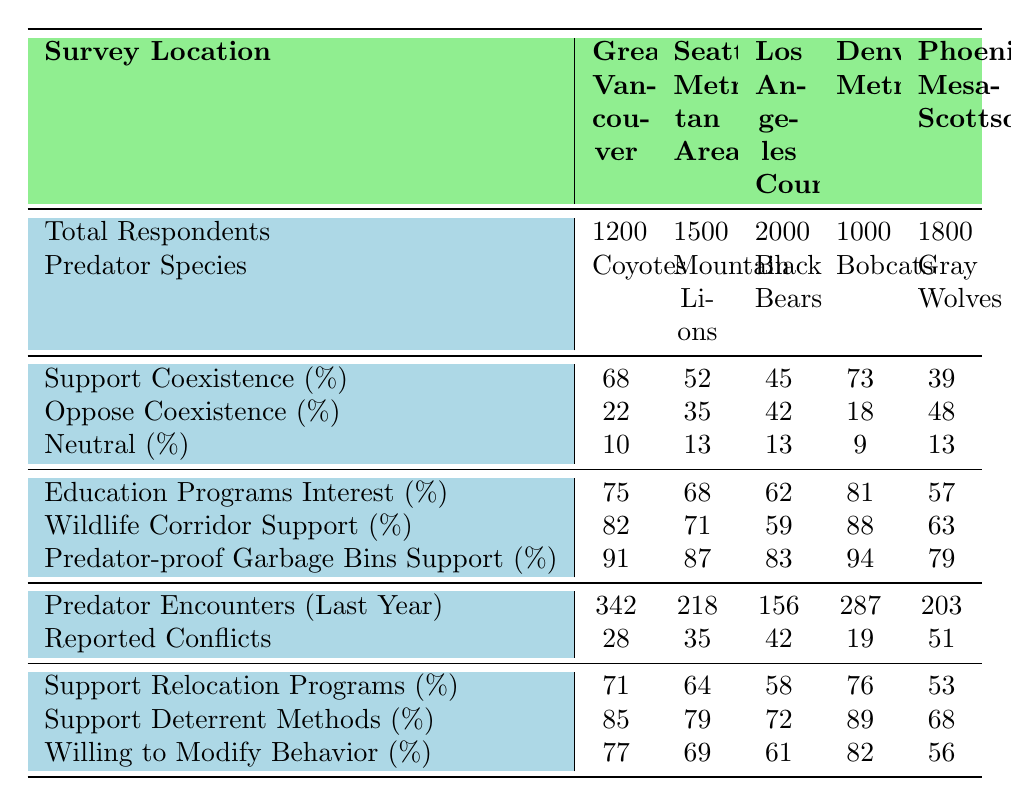What is the support percentage for coexistence in Greater Vancouver? The table shows that the support for coexistence in Greater Vancouver is listed as 68%.
Answer: 68% Which location has the highest reported conflicts? By looking at the reported conflicts column, Phoenix-Mesa-Scottsdale has 51 reported conflicts, which is the highest among all locations listed.
Answer: Phoenix-Mesa-Scottsdale What percentage of respondents in Los Angeles County are neutral about coexistence? The neutral percentage for Los Angeles County, as per the table, is 13%.
Answer: 13% What is the average percentage of support for coexistence across all survey locations? First, sum the support percentages: 68 + 52 + 45 + 73 + 39 = 277. Then, divide by the number of locations (5): 277/5 = 55.4.
Answer: 55.4% Is there a higher percentage of people willing to modify behavior in Greater Vancouver or Denver Metro? Greater Vancouver has 77% willing to modify behavior while Denver Metro has 82%. Since 82% is higher, the answer is Denver Metro.
Answer: Denver Metro What is the difference in predator encounters between Seattle Metropolitan Area and Phoenix-Mesa-Scottsdale? First, identify the encounters: Seattle has 218 and Phoenix has 203. The difference is 218 - 203 = 15.
Answer: 15 Which location shows the lowest willingness to modify behavior? Reviewing the willing to modify behavior column, Phoenix-Mesa-Scottsdale has the lowest percentage at 56%.
Answer: Phoenix-Mesa-Scottsdale In terms of predator-proof garbage bins support, how does Los Angeles County compare with Denver Metro? Los Angeles County has 83% support while Denver Metro has a higher 94%. So, Denver Metro has more support for predator-proof garbage bins.
Answer: Denver Metro What is the total number of respondents across all locations? By adding the total respondents: 1200 + 1500 + 2000 + 1000 + 1800 = 8500.
Answer: 8500 Is the percentage of education program interest in Black Bears greater than 60%? The percentage for Black Bears is 62%, which is greater than 60%. Therefore, the answer is yes.
Answer: Yes What percentage of people in Greater Vancouver oppose coexistence? The table indicates that 22% of respondents in Greater Vancouver oppose coexistence.
Answer: 22% 